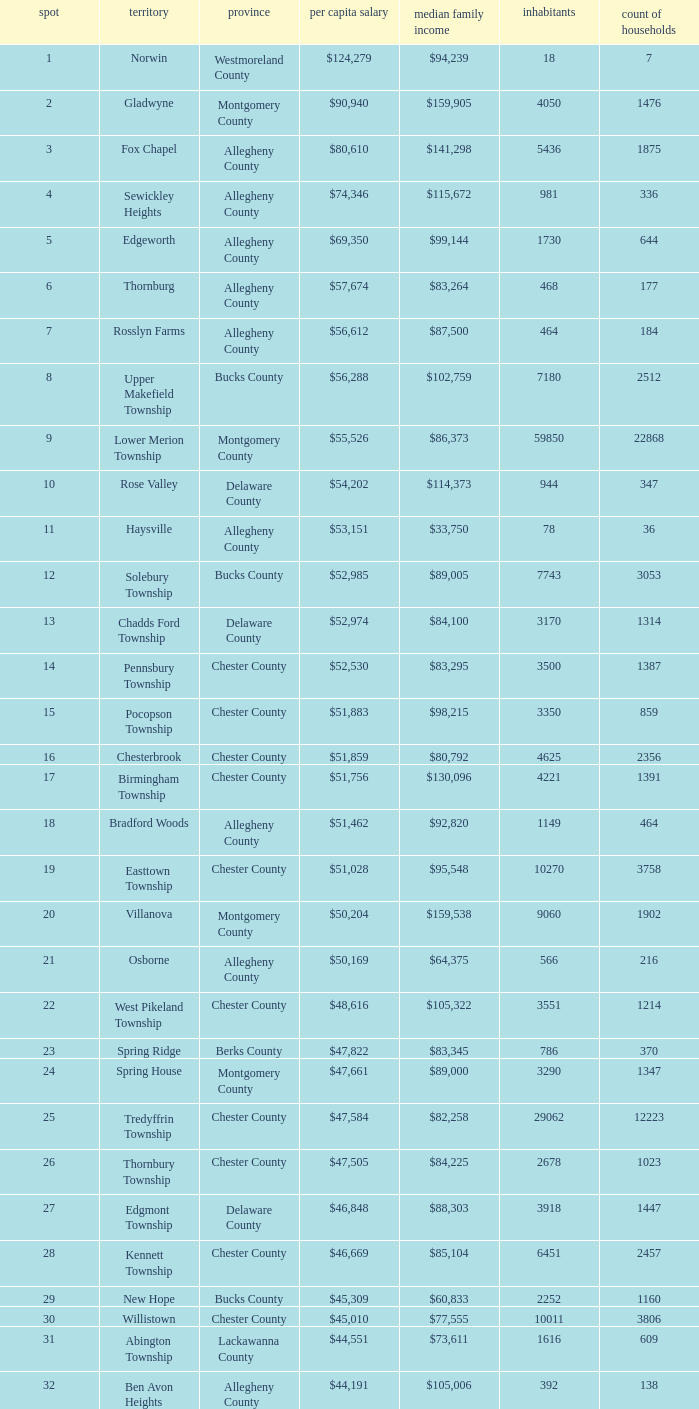What county has 2053 households?  Chester County. Would you be able to parse every entry in this table? {'header': ['spot', 'territory', 'province', 'per capita salary', 'median family income', 'inhabitants', 'count of households'], 'rows': [['1', 'Norwin', 'Westmoreland County', '$124,279', '$94,239', '18', '7'], ['2', 'Gladwyne', 'Montgomery County', '$90,940', '$159,905', '4050', '1476'], ['3', 'Fox Chapel', 'Allegheny County', '$80,610', '$141,298', '5436', '1875'], ['4', 'Sewickley Heights', 'Allegheny County', '$74,346', '$115,672', '981', '336'], ['5', 'Edgeworth', 'Allegheny County', '$69,350', '$99,144', '1730', '644'], ['6', 'Thornburg', 'Allegheny County', '$57,674', '$83,264', '468', '177'], ['7', 'Rosslyn Farms', 'Allegheny County', '$56,612', '$87,500', '464', '184'], ['8', 'Upper Makefield Township', 'Bucks County', '$56,288', '$102,759', '7180', '2512'], ['9', 'Lower Merion Township', 'Montgomery County', '$55,526', '$86,373', '59850', '22868'], ['10', 'Rose Valley', 'Delaware County', '$54,202', '$114,373', '944', '347'], ['11', 'Haysville', 'Allegheny County', '$53,151', '$33,750', '78', '36'], ['12', 'Solebury Township', 'Bucks County', '$52,985', '$89,005', '7743', '3053'], ['13', 'Chadds Ford Township', 'Delaware County', '$52,974', '$84,100', '3170', '1314'], ['14', 'Pennsbury Township', 'Chester County', '$52,530', '$83,295', '3500', '1387'], ['15', 'Pocopson Township', 'Chester County', '$51,883', '$98,215', '3350', '859'], ['16', 'Chesterbrook', 'Chester County', '$51,859', '$80,792', '4625', '2356'], ['17', 'Birmingham Township', 'Chester County', '$51,756', '$130,096', '4221', '1391'], ['18', 'Bradford Woods', 'Allegheny County', '$51,462', '$92,820', '1149', '464'], ['19', 'Easttown Township', 'Chester County', '$51,028', '$95,548', '10270', '3758'], ['20', 'Villanova', 'Montgomery County', '$50,204', '$159,538', '9060', '1902'], ['21', 'Osborne', 'Allegheny County', '$50,169', '$64,375', '566', '216'], ['22', 'West Pikeland Township', 'Chester County', '$48,616', '$105,322', '3551', '1214'], ['23', 'Spring Ridge', 'Berks County', '$47,822', '$83,345', '786', '370'], ['24', 'Spring House', 'Montgomery County', '$47,661', '$89,000', '3290', '1347'], ['25', 'Tredyffrin Township', 'Chester County', '$47,584', '$82,258', '29062', '12223'], ['26', 'Thornbury Township', 'Chester County', '$47,505', '$84,225', '2678', '1023'], ['27', 'Edgmont Township', 'Delaware County', '$46,848', '$88,303', '3918', '1447'], ['28', 'Kennett Township', 'Chester County', '$46,669', '$85,104', '6451', '2457'], ['29', 'New Hope', 'Bucks County', '$45,309', '$60,833', '2252', '1160'], ['30', 'Willistown', 'Chester County', '$45,010', '$77,555', '10011', '3806'], ['31', 'Abington Township', 'Lackawanna County', '$44,551', '$73,611', '1616', '609'], ['32', 'Ben Avon Heights', 'Allegheny County', '$44,191', '$105,006', '392', '138'], ['33', 'Bala-Cynwyd', 'Montgomery County', '$44,027', '$78,932', '9336', '3726'], ['34', 'Lower Makefield Township', 'Bucks County', '$43,983', '$98,090', '32681', '11706'], ['35', 'Blue Bell', 'Montgomery County', '$43,813', '$94,160', '6395', '2434'], ['36', 'West Vincent Township', 'Chester County', '$43,500', '$92,024', '3170', '1077'], ['37', 'Mount Gretna', 'Lebanon County', '$43,470', '$62,917', '242', '117'], ['38', 'Schuylkill Township', 'Chester County', '$43,379', '$86,092', '6960', '2536'], ['39', 'Fort Washington', 'Montgomery County', '$43,090', '$103,469', '3680', '1161'], ['40', 'Marshall Township', 'Allegheny County', '$42,856', '$102,351', '5996', '1944'], ['41', 'Woodside', 'Bucks County', '$42,653', '$121,151', '2575', '791'], ['42', 'Wrightstown Township', 'Bucks County', '$42,623', '$82,875', '2839', '971'], ['43', 'Upper St.Clair Township', 'Allegheny County', '$42,413', '$87,581', '20053', '6966'], ['44', 'Seven Springs', 'Fayette County', '$42,131', '$48,750', '127', '63'], ['45', 'Charlestown Township', 'Chester County', '$41,878', '$89,813', '4051', '1340'], ['46', 'Lower Gwynedd Township', 'Montgomery County', '$41,868', '$74,351', '10422', '4177'], ['47', 'Whitpain Township', 'Montgomery County', '$41,739', '$88,933', '18562', '6960'], ['48', 'Bell Acres', 'Allegheny County', '$41,202', '$61,094', '1382', '520'], ['49', 'Penn Wynne', 'Montgomery County', '$41,199', '$78,398', '5382', '2072'], ['50', 'East Bradford Township', 'Chester County', '$41,158', '$100,732', '9405', '3076'], ['51', 'Swarthmore', 'Delaware County', '$40,482', '$82,653', '6170', '1993'], ['52', 'Lafayette Hill', 'Montgomery County', '$40,363', '$84,835', '10226', '3783'], ['53', 'Lower Moreland Township', 'Montgomery County', '$40,129', '$82,597', '11281', '4112'], ['54', 'Radnor Township', 'Delaware County', '$39,813', '$74,272', '30878', '10347'], ['55', 'Whitemarsh Township', 'Montgomery County', '$39,785', '$78,630', '16702', '6179'], ['56', 'Upper Providence Township', 'Delaware County', '$39,532', '$71,166', '10509', '4075'], ['57', 'Newtown Township', 'Delaware County', '$39,364', '$65,924', '11700', '4549'], ['58', 'Adams Township', 'Butler County', '$39,204', '$65,357', '6774', '2382'], ['59', 'Edgewood', 'Allegheny County', '$39,188', '$52,153', '3311', '1639'], ['60', 'Dresher', 'Montgomery County', '$38,865', '$99,231', '5610', '1765'], ['61', 'Sewickley Hills', 'Allegheny County', '$38,681', '$79,466', '652', '225'], ['62', 'Exton', 'Chester County', '$38,589', '$68,240', '4267', '2053'], ['63', 'East Marlborough Township', 'Chester County', '$38,090', '$95,812', '6317', '2131'], ['64', 'Doylestown Township', 'Bucks County', '$38,031', '$81,226', '17619', '5999'], ['65', 'Upper Dublin Township', 'Montgomery County', '$37,994', '$80,093', '25878', '9174'], ['66', 'Churchill', 'Allegheny County', '$37,964', '$67,321', '3566', '1519'], ['67', 'Franklin Park', 'Allegheny County', '$37,924', '$87,627', '11364', '3866'], ['68', 'East Goshen Township', 'Chester County', '$37,775', '$64,777', '16824', '7165'], ['69', 'Chester Heights', 'Delaware County', '$37,707', '$70,236', '2481', '1056'], ['70', 'McMurray', 'Washington County', '$37,364', '$81,736', '4726', '1582'], ['71', 'Wyomissing', 'Berks County', '$37,313', '$54,681', '8587', '3359'], ['72', 'Heath Township', 'Jefferson County', '$37,309', '$42,500', '160', '77'], ['73', 'Aleppo Township', 'Allegheny County', '$37,187', '$59,167', '1039', '483'], ['74', 'Westtown Township', 'Chester County', '$36,894', '$85,049', '10352', '3705'], ['75', 'Thompsonville', 'Washington County', '$36,853', '$75,000', '3592', '1228'], ['76', 'Flying Hills', 'Berks County', '$36,822', '$59,596', '1191', '592'], ['77', 'Newlin Township', 'Chester County', '$36,804', '$68,828', '1150', '429'], ['78', 'Wyndmoor', 'Montgomery County', '$36,205', '$72,219', '5601', '2144'], ['79', 'Peters Township', 'Washington County', '$36,159', '$77,442', '17566', '6026'], ['80', 'Ardmore', 'Montgomery County', '$36,111', '$60,966', '12616', '5529'], ['81', 'Clarks Green', 'Lackawanna County', '$35,975', '$61,250', '1630', '616'], ['82', 'London Britain Township', 'Chester County', '$35,761', '$93,521', '2797', '957'], ['83', 'Buckingham Township', 'Bucks County', '$35,735', '$82,376', '16422', '5711'], ['84', 'Devon-Berwyn', 'Chester County', '$35,551', '$74,886', '5067', '1978'], ['85', 'North Abington Township', 'Lackawanna County', '$35,537', '$57,917', '782', '258'], ['86', 'Malvern', 'Chester County', '$35,477', '$62,308', '3059', '1361'], ['87', 'Pine Township', 'Allegheny County', '$35,202', '$85,817', '7683', '2411'], ['88', 'Narberth', 'Montgomery County', '$35,165', '$60,408', '4233', '1904'], ['89', 'West Whiteland Township', 'Chester County', '$35,031', '$71,545', '16499', '6618'], ['90', 'Timber Hills', 'Lebanon County', '$34,974', '$55,938', '329', '157'], ['91', 'Upper Merion Township', 'Montgomery County', '$34,961', '$65,636', '26863', '11575'], ['92', 'Homewood', 'Beaver County', '$34,486', '$33,333', '147', '59'], ['93', 'Newtown Township', 'Bucks County', '$34,335', '$80,532', '18206', '6761'], ['94', 'Tinicum Township', 'Bucks County', '$34,321', '$60,843', '4206', '1674'], ['95', 'Worcester Township', 'Montgomery County', '$34,264', '$77,200', '7789', '2896'], ['96', 'Wyomissing Hills', 'Berks County', '$34,024', '$61,364', '2568', '986'], ['97', 'Woodbourne', 'Bucks County', '$33,821', '$107,913', '3512', '1008'], ['98', 'Concord Township', 'Delaware County', '$33,800', '$85,503', '9933', '3384'], ['99', 'Uwchlan Township', 'Chester County', '$33,785', '$81,985', '16576', '5921']]} 